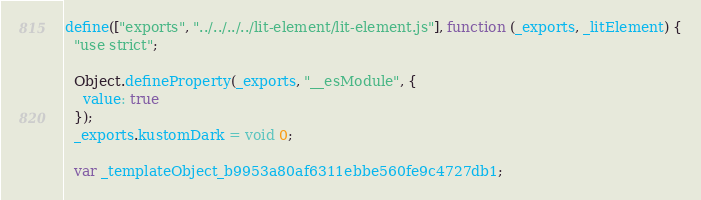Convert code to text. <code><loc_0><loc_0><loc_500><loc_500><_JavaScript_>define(["exports", "../../../../lit-element/lit-element.js"], function (_exports, _litElement) {
  "use strict";

  Object.defineProperty(_exports, "__esModule", {
    value: true
  });
  _exports.kustomDark = void 0;

  var _templateObject_b9953a80af6311ebbe560fe9c4727db1;
</code> 